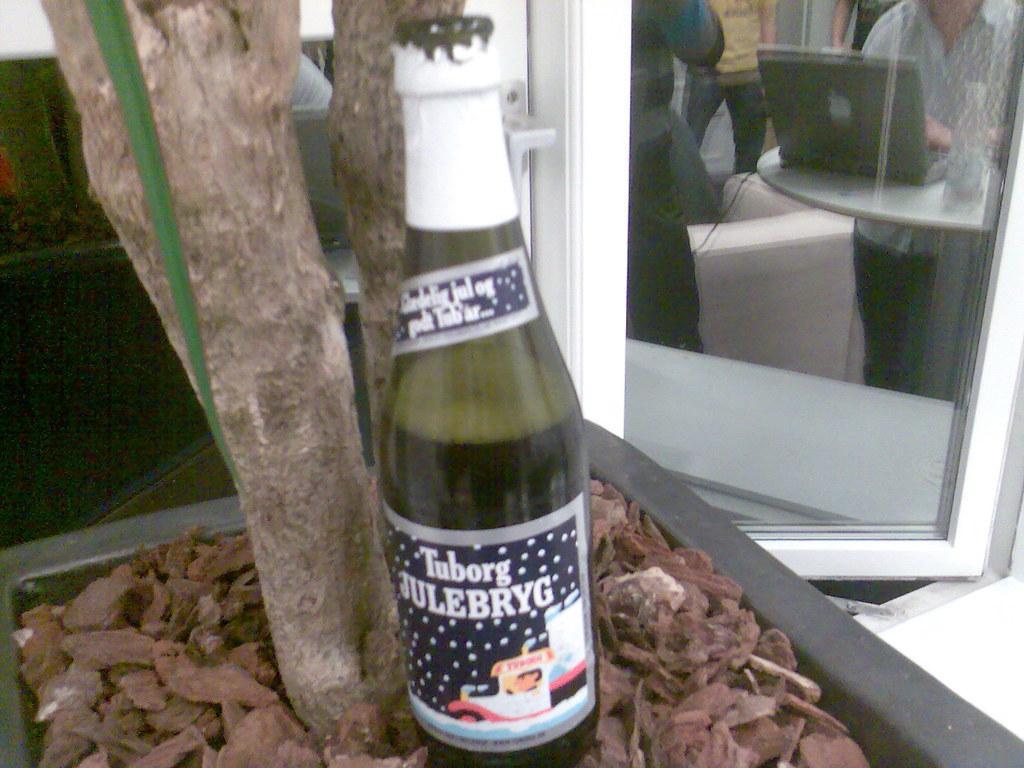Please provide a concise description of this image. This is a beer bottle which is on the clay pot. In this glass window we can see a man working on a laptop which is on the table. 